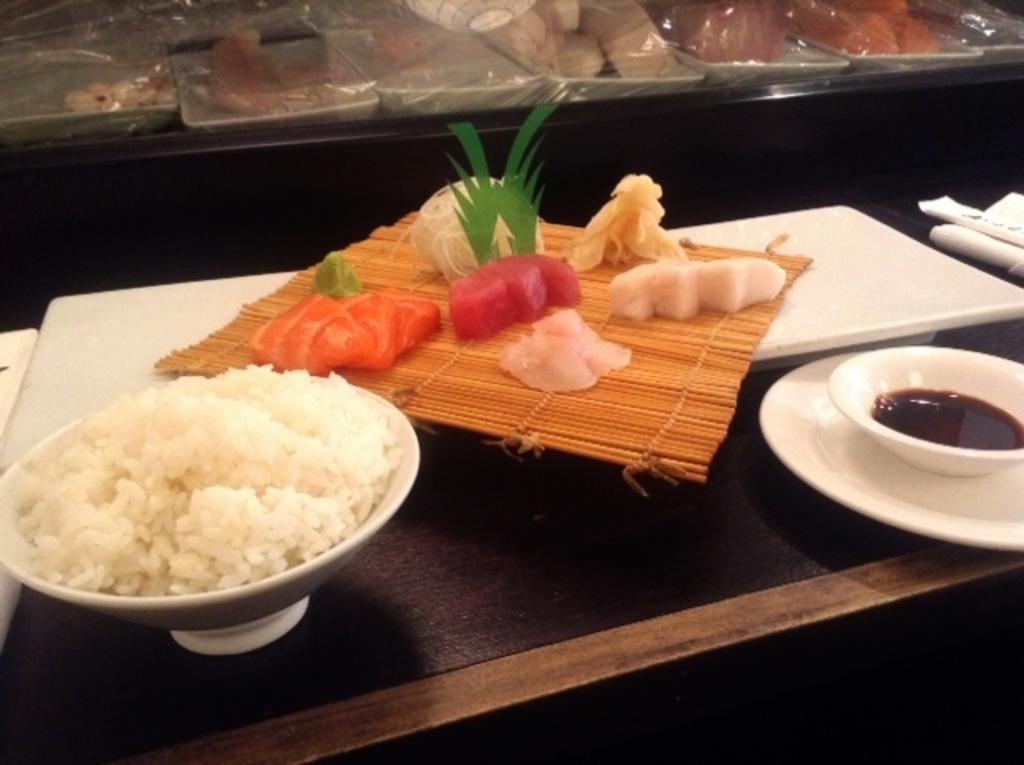Can you describe this image briefly? In the middle of this image, there are food items arranged on a table. In the background, there are food items arranged and covered with plastic cover on another table. And the background is dark in color. 